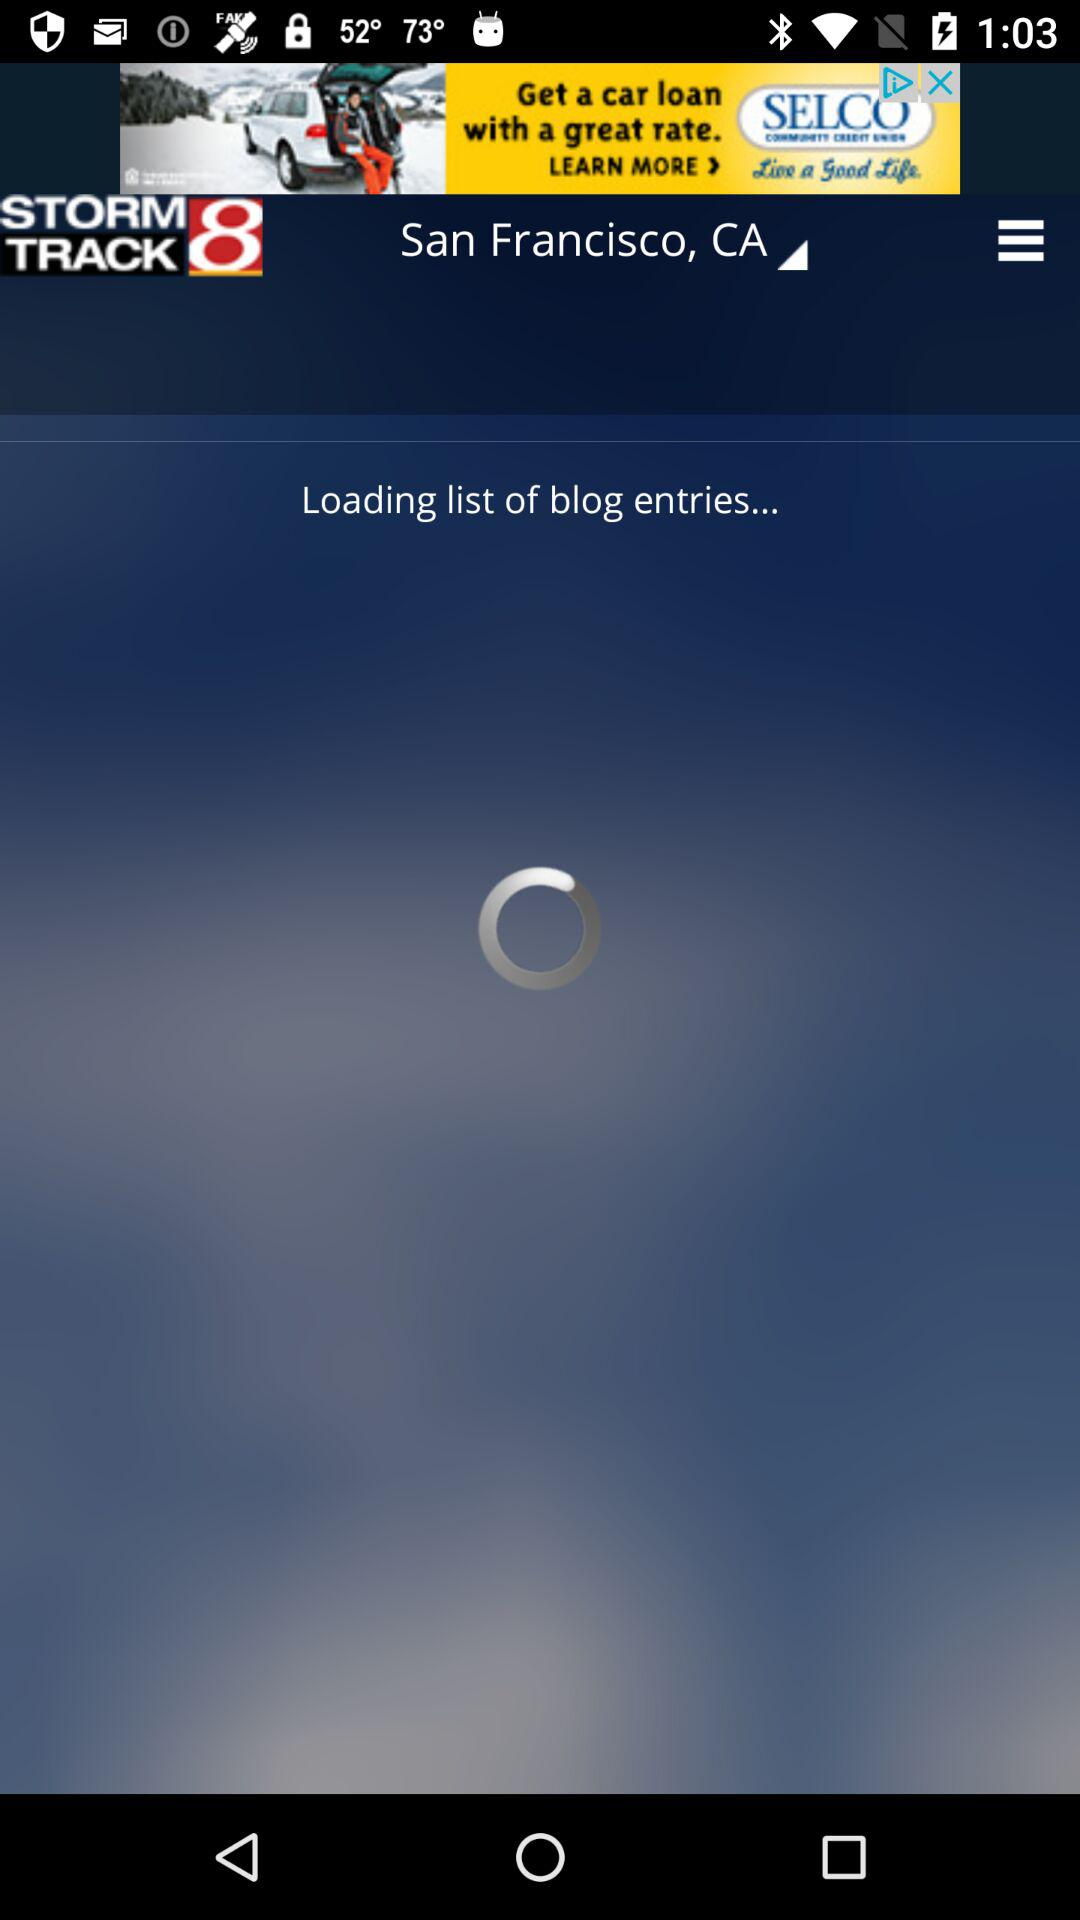What is the name of the application? The name of the application is "STORM TRACK 8". 